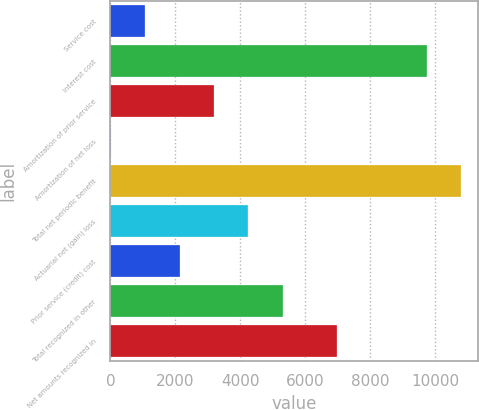Convert chart to OTSL. <chart><loc_0><loc_0><loc_500><loc_500><bar_chart><fcel>Service cost<fcel>Interest cost<fcel>Amortization of prior service<fcel>Amortization of net loss<fcel>Total net periodic benefit<fcel>Actuarial net (gain) loss<fcel>Prior service (credit) cost<fcel>Total recognized in other<fcel>Net amounts recognized in<nl><fcel>1070.9<fcel>9731<fcel>3186.7<fcel>13<fcel>10788.9<fcel>4244.6<fcel>2128.8<fcel>5302.5<fcel>6973<nl></chart> 